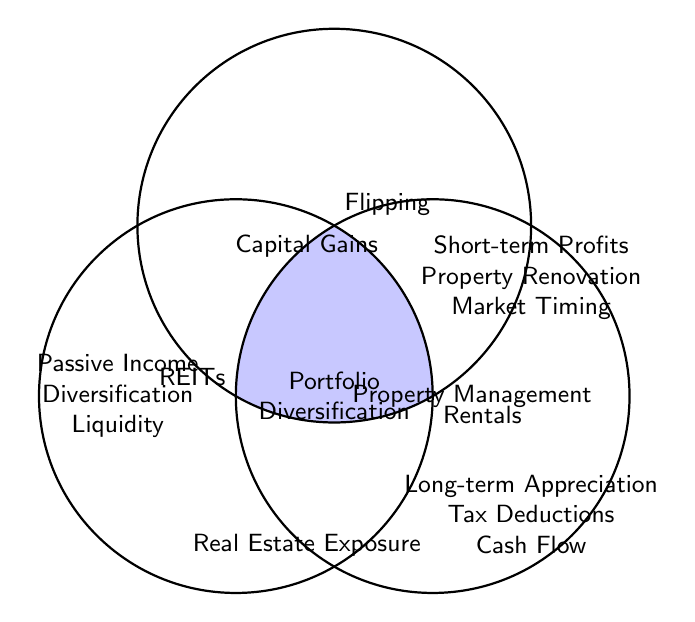How many investment strategies are listed for REITs alone? The figure shows three strategies under REITs alone: Passive Income, Diversification, and Liquidity.
Answer: 3 Which strategy is common to all three investment types? The center of the Venn Diagram lists the strategy common to all three investments: Portfolio Diversification.
Answer: Portfolio Diversification What are the benefits exclusive to Flipping investments? The section labeled 'Flipping' lists the benefits exclusive to Flipping: Short-term Profits, Property Renovation, and Market Timing.
Answer: Short-term Profits, Property Renovation, Market Timing How many strategies are unique to Rentals? The area exclusive to Rentals lists three strategies: Long-term Appreciation, Tax Deductions, and Cash Flow.
Answer: 3 Which type of investments share the strategy of Real Estate Exposure? The Venn Diagram shows that Real Estate Exposure is shared by REITs and Rentals.
Answer: REITs and Rentals Name the benefits exclusive to REITs and Flipping combined. The overlapping section between REITs and Flipping has one benefit listed: Capital Gains.
Answer: Capital Gains Which investment types share Property Management? The overlap area between Flipping and Rentals specifies Property Management.
Answer: Flipping and Rentals Identify the strategies common to both REITs and Rentals. The intersecting section between REITs and Rentals lists Real Estate Exposure.
Answer: Real Estate Exposure How many strategies are listed for each investment type combined (REITs, Flipping, Rentals)? By counting listed strategies in REITs, Flipping, and Rentals: REITs (3), Flipping (3), Rentals (3), and adding jointly shared (Capital Gains, Real Estate Exposure, Property Management), total: 3 (REITs) + 3 (Flipping) + 3 (Rentals) - 3 shared + 4 all combined = 10 unique strategies.
Answer: 10 Is there any strategy listed that is common to three but not unique to each combination of two? Portfolio Diversification is common to all three types, which isn't a combination of just two sets alone.
Answer: Portfolio Diversification 